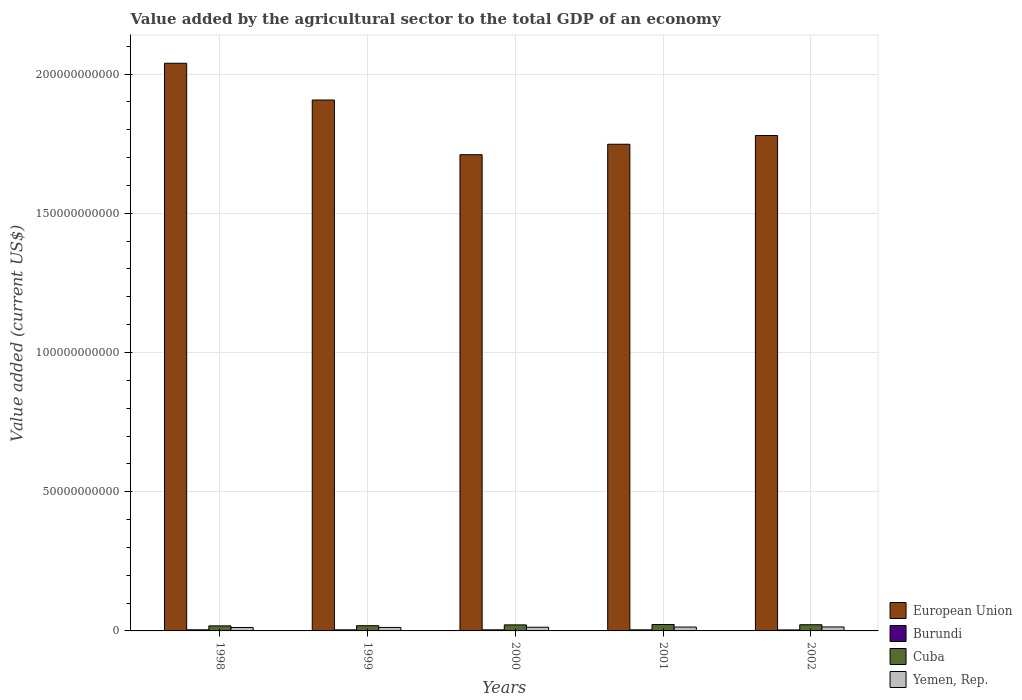How many groups of bars are there?
Offer a terse response. 5. Are the number of bars per tick equal to the number of legend labels?
Your response must be concise. Yes. Are the number of bars on each tick of the X-axis equal?
Your answer should be very brief. Yes. How many bars are there on the 4th tick from the left?
Offer a terse response. 4. What is the value added by the agricultural sector to the total GDP in European Union in 2002?
Offer a terse response. 1.78e+11. Across all years, what is the maximum value added by the agricultural sector to the total GDP in European Union?
Your response must be concise. 2.04e+11. Across all years, what is the minimum value added by the agricultural sector to the total GDP in Burundi?
Your answer should be very brief. 3.58e+08. In which year was the value added by the agricultural sector to the total GDP in Cuba maximum?
Your response must be concise. 2001. What is the total value added by the agricultural sector to the total GDP in Cuba in the graph?
Your answer should be compact. 1.04e+1. What is the difference between the value added by the agricultural sector to the total GDP in Yemen, Rep. in 1998 and that in 1999?
Offer a very short reply. -1.84e+07. What is the difference between the value added by the agricultural sector to the total GDP in Burundi in 1998 and the value added by the agricultural sector to the total GDP in European Union in 2002?
Offer a terse response. -1.78e+11. What is the average value added by the agricultural sector to the total GDP in European Union per year?
Provide a succinct answer. 1.84e+11. In the year 2001, what is the difference between the value added by the agricultural sector to the total GDP in European Union and value added by the agricultural sector to the total GDP in Burundi?
Offer a very short reply. 1.74e+11. In how many years, is the value added by the agricultural sector to the total GDP in Cuba greater than 30000000000 US$?
Give a very brief answer. 0. What is the ratio of the value added by the agricultural sector to the total GDP in Burundi in 1999 to that in 2001?
Your answer should be very brief. 1. What is the difference between the highest and the second highest value added by the agricultural sector to the total GDP in Yemen, Rep.?
Ensure brevity in your answer.  3.58e+07. What is the difference between the highest and the lowest value added by the agricultural sector to the total GDP in Cuba?
Your answer should be very brief. 4.77e+08. Is the sum of the value added by the agricultural sector to the total GDP in Cuba in 2001 and 2002 greater than the maximum value added by the agricultural sector to the total GDP in European Union across all years?
Your response must be concise. No. Is it the case that in every year, the sum of the value added by the agricultural sector to the total GDP in Yemen, Rep. and value added by the agricultural sector to the total GDP in Burundi is greater than the sum of value added by the agricultural sector to the total GDP in Cuba and value added by the agricultural sector to the total GDP in European Union?
Your response must be concise. Yes. What does the 2nd bar from the left in 1999 represents?
Provide a short and direct response. Burundi. Are the values on the major ticks of Y-axis written in scientific E-notation?
Offer a very short reply. No. Does the graph contain any zero values?
Ensure brevity in your answer.  No. Where does the legend appear in the graph?
Provide a succinct answer. Bottom right. How are the legend labels stacked?
Make the answer very short. Vertical. What is the title of the graph?
Offer a terse response. Value added by the agricultural sector to the total GDP of an economy. What is the label or title of the X-axis?
Provide a short and direct response. Years. What is the label or title of the Y-axis?
Ensure brevity in your answer.  Value added (current US$). What is the Value added (current US$) of European Union in 1998?
Provide a short and direct response. 2.04e+11. What is the Value added (current US$) of Burundi in 1998?
Keep it short and to the point. 3.98e+08. What is the Value added (current US$) in Cuba in 1998?
Ensure brevity in your answer.  1.82e+09. What is the Value added (current US$) in Yemen, Rep. in 1998?
Provide a short and direct response. 1.24e+09. What is the Value added (current US$) in European Union in 1999?
Keep it short and to the point. 1.91e+11. What is the Value added (current US$) in Burundi in 1999?
Your answer should be very brief. 3.85e+08. What is the Value added (current US$) in Cuba in 1999?
Offer a very short reply. 1.87e+09. What is the Value added (current US$) of Yemen, Rep. in 1999?
Make the answer very short. 1.26e+09. What is the Value added (current US$) in European Union in 2000?
Offer a terse response. 1.71e+11. What is the Value added (current US$) of Burundi in 2000?
Keep it short and to the point. 3.84e+08. What is the Value added (current US$) of Cuba in 2000?
Offer a very short reply. 2.17e+09. What is the Value added (current US$) of Yemen, Rep. in 2000?
Provide a succinct answer. 1.33e+09. What is the Value added (current US$) of European Union in 2001?
Make the answer very short. 1.75e+11. What is the Value added (current US$) of Burundi in 2001?
Your response must be concise. 3.84e+08. What is the Value added (current US$) of Cuba in 2001?
Your response must be concise. 2.29e+09. What is the Value added (current US$) of Yemen, Rep. in 2001?
Ensure brevity in your answer.  1.39e+09. What is the Value added (current US$) in European Union in 2002?
Your answer should be very brief. 1.78e+11. What is the Value added (current US$) in Burundi in 2002?
Provide a succinct answer. 3.58e+08. What is the Value added (current US$) of Cuba in 2002?
Ensure brevity in your answer.  2.23e+09. What is the Value added (current US$) in Yemen, Rep. in 2002?
Your answer should be compact. 1.43e+09. Across all years, what is the maximum Value added (current US$) in European Union?
Your answer should be compact. 2.04e+11. Across all years, what is the maximum Value added (current US$) of Burundi?
Make the answer very short. 3.98e+08. Across all years, what is the maximum Value added (current US$) in Cuba?
Make the answer very short. 2.29e+09. Across all years, what is the maximum Value added (current US$) in Yemen, Rep.?
Your answer should be compact. 1.43e+09. Across all years, what is the minimum Value added (current US$) in European Union?
Give a very brief answer. 1.71e+11. Across all years, what is the minimum Value added (current US$) of Burundi?
Ensure brevity in your answer.  3.58e+08. Across all years, what is the minimum Value added (current US$) in Cuba?
Ensure brevity in your answer.  1.82e+09. Across all years, what is the minimum Value added (current US$) of Yemen, Rep.?
Ensure brevity in your answer.  1.24e+09. What is the total Value added (current US$) of European Union in the graph?
Provide a short and direct response. 9.18e+11. What is the total Value added (current US$) in Burundi in the graph?
Keep it short and to the point. 1.91e+09. What is the total Value added (current US$) of Cuba in the graph?
Ensure brevity in your answer.  1.04e+1. What is the total Value added (current US$) of Yemen, Rep. in the graph?
Keep it short and to the point. 6.64e+09. What is the difference between the Value added (current US$) in European Union in 1998 and that in 1999?
Your answer should be compact. 1.32e+1. What is the difference between the Value added (current US$) of Burundi in 1998 and that in 1999?
Offer a very short reply. 1.31e+07. What is the difference between the Value added (current US$) in Cuba in 1998 and that in 1999?
Give a very brief answer. -5.87e+07. What is the difference between the Value added (current US$) in Yemen, Rep. in 1998 and that in 1999?
Your answer should be compact. -1.84e+07. What is the difference between the Value added (current US$) of European Union in 1998 and that in 2000?
Your response must be concise. 3.29e+1. What is the difference between the Value added (current US$) in Burundi in 1998 and that in 2000?
Offer a terse response. 1.41e+07. What is the difference between the Value added (current US$) of Cuba in 1998 and that in 2000?
Your answer should be compact. -3.51e+08. What is the difference between the Value added (current US$) in Yemen, Rep. in 1998 and that in 2000?
Your answer should be very brief. -8.93e+07. What is the difference between the Value added (current US$) in European Union in 1998 and that in 2001?
Keep it short and to the point. 2.91e+1. What is the difference between the Value added (current US$) in Burundi in 1998 and that in 2001?
Your answer should be compact. 1.37e+07. What is the difference between the Value added (current US$) of Cuba in 1998 and that in 2001?
Your response must be concise. -4.77e+08. What is the difference between the Value added (current US$) in Yemen, Rep. in 1998 and that in 2001?
Offer a very short reply. -1.54e+08. What is the difference between the Value added (current US$) of European Union in 1998 and that in 2002?
Give a very brief answer. 2.60e+1. What is the difference between the Value added (current US$) in Burundi in 1998 and that in 2002?
Provide a short and direct response. 4.04e+07. What is the difference between the Value added (current US$) of Cuba in 1998 and that in 2002?
Provide a short and direct response. -4.10e+08. What is the difference between the Value added (current US$) of Yemen, Rep. in 1998 and that in 2002?
Give a very brief answer. -1.89e+08. What is the difference between the Value added (current US$) in European Union in 1999 and that in 2000?
Your answer should be compact. 1.96e+1. What is the difference between the Value added (current US$) in Burundi in 1999 and that in 2000?
Keep it short and to the point. 9.84e+05. What is the difference between the Value added (current US$) of Cuba in 1999 and that in 2000?
Your answer should be compact. -2.92e+08. What is the difference between the Value added (current US$) in Yemen, Rep. in 1999 and that in 2000?
Make the answer very short. -7.09e+07. What is the difference between the Value added (current US$) of European Union in 1999 and that in 2001?
Keep it short and to the point. 1.59e+1. What is the difference between the Value added (current US$) of Burundi in 1999 and that in 2001?
Keep it short and to the point. 5.16e+05. What is the difference between the Value added (current US$) of Cuba in 1999 and that in 2001?
Keep it short and to the point. -4.18e+08. What is the difference between the Value added (current US$) of Yemen, Rep. in 1999 and that in 2001?
Offer a very short reply. -1.35e+08. What is the difference between the Value added (current US$) of European Union in 1999 and that in 2002?
Your answer should be very brief. 1.28e+1. What is the difference between the Value added (current US$) in Burundi in 1999 and that in 2002?
Provide a short and direct response. 2.73e+07. What is the difference between the Value added (current US$) in Cuba in 1999 and that in 2002?
Offer a terse response. -3.51e+08. What is the difference between the Value added (current US$) of Yemen, Rep. in 1999 and that in 2002?
Keep it short and to the point. -1.71e+08. What is the difference between the Value added (current US$) in European Union in 2000 and that in 2001?
Keep it short and to the point. -3.76e+09. What is the difference between the Value added (current US$) in Burundi in 2000 and that in 2001?
Your response must be concise. -4.69e+05. What is the difference between the Value added (current US$) in Cuba in 2000 and that in 2001?
Your answer should be compact. -1.26e+08. What is the difference between the Value added (current US$) in Yemen, Rep. in 2000 and that in 2001?
Offer a very short reply. -6.42e+07. What is the difference between the Value added (current US$) of European Union in 2000 and that in 2002?
Your answer should be very brief. -6.90e+09. What is the difference between the Value added (current US$) of Burundi in 2000 and that in 2002?
Offer a terse response. 2.63e+07. What is the difference between the Value added (current US$) in Cuba in 2000 and that in 2002?
Your answer should be very brief. -5.92e+07. What is the difference between the Value added (current US$) of Yemen, Rep. in 2000 and that in 2002?
Ensure brevity in your answer.  -1.00e+08. What is the difference between the Value added (current US$) in European Union in 2001 and that in 2002?
Your response must be concise. -3.14e+09. What is the difference between the Value added (current US$) in Burundi in 2001 and that in 2002?
Offer a terse response. 2.67e+07. What is the difference between the Value added (current US$) in Cuba in 2001 and that in 2002?
Provide a short and direct response. 6.67e+07. What is the difference between the Value added (current US$) of Yemen, Rep. in 2001 and that in 2002?
Your response must be concise. -3.58e+07. What is the difference between the Value added (current US$) in European Union in 1998 and the Value added (current US$) in Burundi in 1999?
Your answer should be compact. 2.04e+11. What is the difference between the Value added (current US$) in European Union in 1998 and the Value added (current US$) in Cuba in 1999?
Give a very brief answer. 2.02e+11. What is the difference between the Value added (current US$) in European Union in 1998 and the Value added (current US$) in Yemen, Rep. in 1999?
Ensure brevity in your answer.  2.03e+11. What is the difference between the Value added (current US$) of Burundi in 1998 and the Value added (current US$) of Cuba in 1999?
Offer a terse response. -1.48e+09. What is the difference between the Value added (current US$) in Burundi in 1998 and the Value added (current US$) in Yemen, Rep. in 1999?
Provide a succinct answer. -8.58e+08. What is the difference between the Value added (current US$) in Cuba in 1998 and the Value added (current US$) in Yemen, Rep. in 1999?
Keep it short and to the point. 5.60e+08. What is the difference between the Value added (current US$) of European Union in 1998 and the Value added (current US$) of Burundi in 2000?
Ensure brevity in your answer.  2.04e+11. What is the difference between the Value added (current US$) in European Union in 1998 and the Value added (current US$) in Cuba in 2000?
Make the answer very short. 2.02e+11. What is the difference between the Value added (current US$) in European Union in 1998 and the Value added (current US$) in Yemen, Rep. in 2000?
Offer a very short reply. 2.03e+11. What is the difference between the Value added (current US$) of Burundi in 1998 and the Value added (current US$) of Cuba in 2000?
Keep it short and to the point. -1.77e+09. What is the difference between the Value added (current US$) of Burundi in 1998 and the Value added (current US$) of Yemen, Rep. in 2000?
Ensure brevity in your answer.  -9.29e+08. What is the difference between the Value added (current US$) in Cuba in 1998 and the Value added (current US$) in Yemen, Rep. in 2000?
Your answer should be very brief. 4.89e+08. What is the difference between the Value added (current US$) in European Union in 1998 and the Value added (current US$) in Burundi in 2001?
Make the answer very short. 2.04e+11. What is the difference between the Value added (current US$) of European Union in 1998 and the Value added (current US$) of Cuba in 2001?
Ensure brevity in your answer.  2.02e+11. What is the difference between the Value added (current US$) of European Union in 1998 and the Value added (current US$) of Yemen, Rep. in 2001?
Your answer should be very brief. 2.03e+11. What is the difference between the Value added (current US$) in Burundi in 1998 and the Value added (current US$) in Cuba in 2001?
Provide a succinct answer. -1.89e+09. What is the difference between the Value added (current US$) in Burundi in 1998 and the Value added (current US$) in Yemen, Rep. in 2001?
Your answer should be compact. -9.93e+08. What is the difference between the Value added (current US$) in Cuba in 1998 and the Value added (current US$) in Yemen, Rep. in 2001?
Keep it short and to the point. 4.25e+08. What is the difference between the Value added (current US$) in European Union in 1998 and the Value added (current US$) in Burundi in 2002?
Offer a very short reply. 2.04e+11. What is the difference between the Value added (current US$) in European Union in 1998 and the Value added (current US$) in Cuba in 2002?
Offer a terse response. 2.02e+11. What is the difference between the Value added (current US$) of European Union in 1998 and the Value added (current US$) of Yemen, Rep. in 2002?
Your answer should be compact. 2.02e+11. What is the difference between the Value added (current US$) in Burundi in 1998 and the Value added (current US$) in Cuba in 2002?
Your answer should be compact. -1.83e+09. What is the difference between the Value added (current US$) in Burundi in 1998 and the Value added (current US$) in Yemen, Rep. in 2002?
Provide a succinct answer. -1.03e+09. What is the difference between the Value added (current US$) of Cuba in 1998 and the Value added (current US$) of Yemen, Rep. in 2002?
Offer a very short reply. 3.89e+08. What is the difference between the Value added (current US$) of European Union in 1999 and the Value added (current US$) of Burundi in 2000?
Keep it short and to the point. 1.90e+11. What is the difference between the Value added (current US$) in European Union in 1999 and the Value added (current US$) in Cuba in 2000?
Offer a very short reply. 1.89e+11. What is the difference between the Value added (current US$) in European Union in 1999 and the Value added (current US$) in Yemen, Rep. in 2000?
Make the answer very short. 1.89e+11. What is the difference between the Value added (current US$) in Burundi in 1999 and the Value added (current US$) in Cuba in 2000?
Give a very brief answer. -1.78e+09. What is the difference between the Value added (current US$) of Burundi in 1999 and the Value added (current US$) of Yemen, Rep. in 2000?
Make the answer very short. -9.42e+08. What is the difference between the Value added (current US$) in Cuba in 1999 and the Value added (current US$) in Yemen, Rep. in 2000?
Provide a short and direct response. 5.47e+08. What is the difference between the Value added (current US$) of European Union in 1999 and the Value added (current US$) of Burundi in 2001?
Your answer should be very brief. 1.90e+11. What is the difference between the Value added (current US$) in European Union in 1999 and the Value added (current US$) in Cuba in 2001?
Offer a very short reply. 1.88e+11. What is the difference between the Value added (current US$) in European Union in 1999 and the Value added (current US$) in Yemen, Rep. in 2001?
Keep it short and to the point. 1.89e+11. What is the difference between the Value added (current US$) in Burundi in 1999 and the Value added (current US$) in Cuba in 2001?
Offer a terse response. -1.91e+09. What is the difference between the Value added (current US$) in Burundi in 1999 and the Value added (current US$) in Yemen, Rep. in 2001?
Offer a terse response. -1.01e+09. What is the difference between the Value added (current US$) in Cuba in 1999 and the Value added (current US$) in Yemen, Rep. in 2001?
Give a very brief answer. 4.83e+08. What is the difference between the Value added (current US$) of European Union in 1999 and the Value added (current US$) of Burundi in 2002?
Give a very brief answer. 1.90e+11. What is the difference between the Value added (current US$) in European Union in 1999 and the Value added (current US$) in Cuba in 2002?
Provide a succinct answer. 1.88e+11. What is the difference between the Value added (current US$) in European Union in 1999 and the Value added (current US$) in Yemen, Rep. in 2002?
Provide a succinct answer. 1.89e+11. What is the difference between the Value added (current US$) in Burundi in 1999 and the Value added (current US$) in Cuba in 2002?
Provide a short and direct response. -1.84e+09. What is the difference between the Value added (current US$) of Burundi in 1999 and the Value added (current US$) of Yemen, Rep. in 2002?
Provide a succinct answer. -1.04e+09. What is the difference between the Value added (current US$) in Cuba in 1999 and the Value added (current US$) in Yemen, Rep. in 2002?
Offer a very short reply. 4.47e+08. What is the difference between the Value added (current US$) of European Union in 2000 and the Value added (current US$) of Burundi in 2001?
Make the answer very short. 1.71e+11. What is the difference between the Value added (current US$) in European Union in 2000 and the Value added (current US$) in Cuba in 2001?
Give a very brief answer. 1.69e+11. What is the difference between the Value added (current US$) in European Union in 2000 and the Value added (current US$) in Yemen, Rep. in 2001?
Keep it short and to the point. 1.70e+11. What is the difference between the Value added (current US$) of Burundi in 2000 and the Value added (current US$) of Cuba in 2001?
Provide a succinct answer. -1.91e+09. What is the difference between the Value added (current US$) in Burundi in 2000 and the Value added (current US$) in Yemen, Rep. in 2001?
Make the answer very short. -1.01e+09. What is the difference between the Value added (current US$) in Cuba in 2000 and the Value added (current US$) in Yemen, Rep. in 2001?
Provide a succinct answer. 7.75e+08. What is the difference between the Value added (current US$) in European Union in 2000 and the Value added (current US$) in Burundi in 2002?
Your answer should be very brief. 1.71e+11. What is the difference between the Value added (current US$) of European Union in 2000 and the Value added (current US$) of Cuba in 2002?
Your response must be concise. 1.69e+11. What is the difference between the Value added (current US$) of European Union in 2000 and the Value added (current US$) of Yemen, Rep. in 2002?
Your answer should be very brief. 1.70e+11. What is the difference between the Value added (current US$) of Burundi in 2000 and the Value added (current US$) of Cuba in 2002?
Offer a very short reply. -1.84e+09. What is the difference between the Value added (current US$) in Burundi in 2000 and the Value added (current US$) in Yemen, Rep. in 2002?
Ensure brevity in your answer.  -1.04e+09. What is the difference between the Value added (current US$) of Cuba in 2000 and the Value added (current US$) of Yemen, Rep. in 2002?
Your answer should be compact. 7.40e+08. What is the difference between the Value added (current US$) in European Union in 2001 and the Value added (current US$) in Burundi in 2002?
Provide a succinct answer. 1.74e+11. What is the difference between the Value added (current US$) in European Union in 2001 and the Value added (current US$) in Cuba in 2002?
Make the answer very short. 1.73e+11. What is the difference between the Value added (current US$) of European Union in 2001 and the Value added (current US$) of Yemen, Rep. in 2002?
Offer a very short reply. 1.73e+11. What is the difference between the Value added (current US$) of Burundi in 2001 and the Value added (current US$) of Cuba in 2002?
Provide a succinct answer. -1.84e+09. What is the difference between the Value added (current US$) of Burundi in 2001 and the Value added (current US$) of Yemen, Rep. in 2002?
Your response must be concise. -1.04e+09. What is the difference between the Value added (current US$) in Cuba in 2001 and the Value added (current US$) in Yemen, Rep. in 2002?
Make the answer very short. 8.65e+08. What is the average Value added (current US$) of European Union per year?
Make the answer very short. 1.84e+11. What is the average Value added (current US$) in Burundi per year?
Offer a terse response. 3.82e+08. What is the average Value added (current US$) in Cuba per year?
Your answer should be very brief. 2.07e+09. What is the average Value added (current US$) in Yemen, Rep. per year?
Keep it short and to the point. 1.33e+09. In the year 1998, what is the difference between the Value added (current US$) in European Union and Value added (current US$) in Burundi?
Your answer should be very brief. 2.04e+11. In the year 1998, what is the difference between the Value added (current US$) of European Union and Value added (current US$) of Cuba?
Offer a very short reply. 2.02e+11. In the year 1998, what is the difference between the Value added (current US$) of European Union and Value added (current US$) of Yemen, Rep.?
Ensure brevity in your answer.  2.03e+11. In the year 1998, what is the difference between the Value added (current US$) of Burundi and Value added (current US$) of Cuba?
Your answer should be very brief. -1.42e+09. In the year 1998, what is the difference between the Value added (current US$) of Burundi and Value added (current US$) of Yemen, Rep.?
Your response must be concise. -8.39e+08. In the year 1998, what is the difference between the Value added (current US$) of Cuba and Value added (current US$) of Yemen, Rep.?
Ensure brevity in your answer.  5.78e+08. In the year 1999, what is the difference between the Value added (current US$) of European Union and Value added (current US$) of Burundi?
Offer a very short reply. 1.90e+11. In the year 1999, what is the difference between the Value added (current US$) of European Union and Value added (current US$) of Cuba?
Provide a short and direct response. 1.89e+11. In the year 1999, what is the difference between the Value added (current US$) of European Union and Value added (current US$) of Yemen, Rep.?
Offer a terse response. 1.89e+11. In the year 1999, what is the difference between the Value added (current US$) in Burundi and Value added (current US$) in Cuba?
Your response must be concise. -1.49e+09. In the year 1999, what is the difference between the Value added (current US$) in Burundi and Value added (current US$) in Yemen, Rep.?
Provide a short and direct response. -8.71e+08. In the year 1999, what is the difference between the Value added (current US$) of Cuba and Value added (current US$) of Yemen, Rep.?
Offer a terse response. 6.18e+08. In the year 2000, what is the difference between the Value added (current US$) of European Union and Value added (current US$) of Burundi?
Provide a short and direct response. 1.71e+11. In the year 2000, what is the difference between the Value added (current US$) of European Union and Value added (current US$) of Cuba?
Provide a succinct answer. 1.69e+11. In the year 2000, what is the difference between the Value added (current US$) in European Union and Value added (current US$) in Yemen, Rep.?
Give a very brief answer. 1.70e+11. In the year 2000, what is the difference between the Value added (current US$) of Burundi and Value added (current US$) of Cuba?
Offer a terse response. -1.78e+09. In the year 2000, what is the difference between the Value added (current US$) of Burundi and Value added (current US$) of Yemen, Rep.?
Provide a short and direct response. -9.43e+08. In the year 2000, what is the difference between the Value added (current US$) in Cuba and Value added (current US$) in Yemen, Rep.?
Offer a very short reply. 8.40e+08. In the year 2001, what is the difference between the Value added (current US$) of European Union and Value added (current US$) of Burundi?
Your answer should be very brief. 1.74e+11. In the year 2001, what is the difference between the Value added (current US$) of European Union and Value added (current US$) of Cuba?
Keep it short and to the point. 1.73e+11. In the year 2001, what is the difference between the Value added (current US$) in European Union and Value added (current US$) in Yemen, Rep.?
Give a very brief answer. 1.73e+11. In the year 2001, what is the difference between the Value added (current US$) in Burundi and Value added (current US$) in Cuba?
Offer a very short reply. -1.91e+09. In the year 2001, what is the difference between the Value added (current US$) in Burundi and Value added (current US$) in Yemen, Rep.?
Your answer should be compact. -1.01e+09. In the year 2001, what is the difference between the Value added (current US$) in Cuba and Value added (current US$) in Yemen, Rep.?
Offer a very short reply. 9.01e+08. In the year 2002, what is the difference between the Value added (current US$) in European Union and Value added (current US$) in Burundi?
Your answer should be very brief. 1.78e+11. In the year 2002, what is the difference between the Value added (current US$) of European Union and Value added (current US$) of Cuba?
Your response must be concise. 1.76e+11. In the year 2002, what is the difference between the Value added (current US$) of European Union and Value added (current US$) of Yemen, Rep.?
Provide a short and direct response. 1.77e+11. In the year 2002, what is the difference between the Value added (current US$) of Burundi and Value added (current US$) of Cuba?
Offer a very short reply. -1.87e+09. In the year 2002, what is the difference between the Value added (current US$) in Burundi and Value added (current US$) in Yemen, Rep.?
Give a very brief answer. -1.07e+09. In the year 2002, what is the difference between the Value added (current US$) of Cuba and Value added (current US$) of Yemen, Rep.?
Provide a short and direct response. 7.99e+08. What is the ratio of the Value added (current US$) of European Union in 1998 to that in 1999?
Provide a short and direct response. 1.07. What is the ratio of the Value added (current US$) of Burundi in 1998 to that in 1999?
Give a very brief answer. 1.03. What is the ratio of the Value added (current US$) in Cuba in 1998 to that in 1999?
Offer a very short reply. 0.97. What is the ratio of the Value added (current US$) in Yemen, Rep. in 1998 to that in 1999?
Offer a terse response. 0.99. What is the ratio of the Value added (current US$) of European Union in 1998 to that in 2000?
Provide a short and direct response. 1.19. What is the ratio of the Value added (current US$) in Burundi in 1998 to that in 2000?
Ensure brevity in your answer.  1.04. What is the ratio of the Value added (current US$) of Cuba in 1998 to that in 2000?
Provide a succinct answer. 0.84. What is the ratio of the Value added (current US$) of Yemen, Rep. in 1998 to that in 2000?
Ensure brevity in your answer.  0.93. What is the ratio of the Value added (current US$) of European Union in 1998 to that in 2001?
Your answer should be compact. 1.17. What is the ratio of the Value added (current US$) of Burundi in 1998 to that in 2001?
Make the answer very short. 1.04. What is the ratio of the Value added (current US$) of Cuba in 1998 to that in 2001?
Provide a succinct answer. 0.79. What is the ratio of the Value added (current US$) of Yemen, Rep. in 1998 to that in 2001?
Offer a very short reply. 0.89. What is the ratio of the Value added (current US$) in European Union in 1998 to that in 2002?
Offer a terse response. 1.15. What is the ratio of the Value added (current US$) of Burundi in 1998 to that in 2002?
Give a very brief answer. 1.11. What is the ratio of the Value added (current US$) of Cuba in 1998 to that in 2002?
Keep it short and to the point. 0.82. What is the ratio of the Value added (current US$) of Yemen, Rep. in 1998 to that in 2002?
Provide a short and direct response. 0.87. What is the ratio of the Value added (current US$) of European Union in 1999 to that in 2000?
Provide a succinct answer. 1.11. What is the ratio of the Value added (current US$) of Burundi in 1999 to that in 2000?
Keep it short and to the point. 1. What is the ratio of the Value added (current US$) in Cuba in 1999 to that in 2000?
Make the answer very short. 0.87. What is the ratio of the Value added (current US$) in Yemen, Rep. in 1999 to that in 2000?
Offer a terse response. 0.95. What is the ratio of the Value added (current US$) in Cuba in 1999 to that in 2001?
Offer a terse response. 0.82. What is the ratio of the Value added (current US$) in Yemen, Rep. in 1999 to that in 2001?
Your response must be concise. 0.9. What is the ratio of the Value added (current US$) of European Union in 1999 to that in 2002?
Keep it short and to the point. 1.07. What is the ratio of the Value added (current US$) in Burundi in 1999 to that in 2002?
Your answer should be very brief. 1.08. What is the ratio of the Value added (current US$) of Cuba in 1999 to that in 2002?
Make the answer very short. 0.84. What is the ratio of the Value added (current US$) of Yemen, Rep. in 1999 to that in 2002?
Ensure brevity in your answer.  0.88. What is the ratio of the Value added (current US$) of European Union in 2000 to that in 2001?
Your answer should be very brief. 0.98. What is the ratio of the Value added (current US$) of Cuba in 2000 to that in 2001?
Offer a very short reply. 0.95. What is the ratio of the Value added (current US$) of Yemen, Rep. in 2000 to that in 2001?
Provide a succinct answer. 0.95. What is the ratio of the Value added (current US$) in European Union in 2000 to that in 2002?
Make the answer very short. 0.96. What is the ratio of the Value added (current US$) of Burundi in 2000 to that in 2002?
Offer a very short reply. 1.07. What is the ratio of the Value added (current US$) of Cuba in 2000 to that in 2002?
Keep it short and to the point. 0.97. What is the ratio of the Value added (current US$) in Yemen, Rep. in 2000 to that in 2002?
Offer a terse response. 0.93. What is the ratio of the Value added (current US$) of European Union in 2001 to that in 2002?
Provide a short and direct response. 0.98. What is the ratio of the Value added (current US$) of Burundi in 2001 to that in 2002?
Provide a succinct answer. 1.07. What is the ratio of the Value added (current US$) in Cuba in 2001 to that in 2002?
Give a very brief answer. 1.03. What is the ratio of the Value added (current US$) in Yemen, Rep. in 2001 to that in 2002?
Offer a terse response. 0.97. What is the difference between the highest and the second highest Value added (current US$) of European Union?
Keep it short and to the point. 1.32e+1. What is the difference between the highest and the second highest Value added (current US$) in Burundi?
Your response must be concise. 1.31e+07. What is the difference between the highest and the second highest Value added (current US$) of Cuba?
Make the answer very short. 6.67e+07. What is the difference between the highest and the second highest Value added (current US$) in Yemen, Rep.?
Offer a terse response. 3.58e+07. What is the difference between the highest and the lowest Value added (current US$) of European Union?
Provide a short and direct response. 3.29e+1. What is the difference between the highest and the lowest Value added (current US$) of Burundi?
Your answer should be compact. 4.04e+07. What is the difference between the highest and the lowest Value added (current US$) in Cuba?
Provide a succinct answer. 4.77e+08. What is the difference between the highest and the lowest Value added (current US$) of Yemen, Rep.?
Provide a short and direct response. 1.89e+08. 